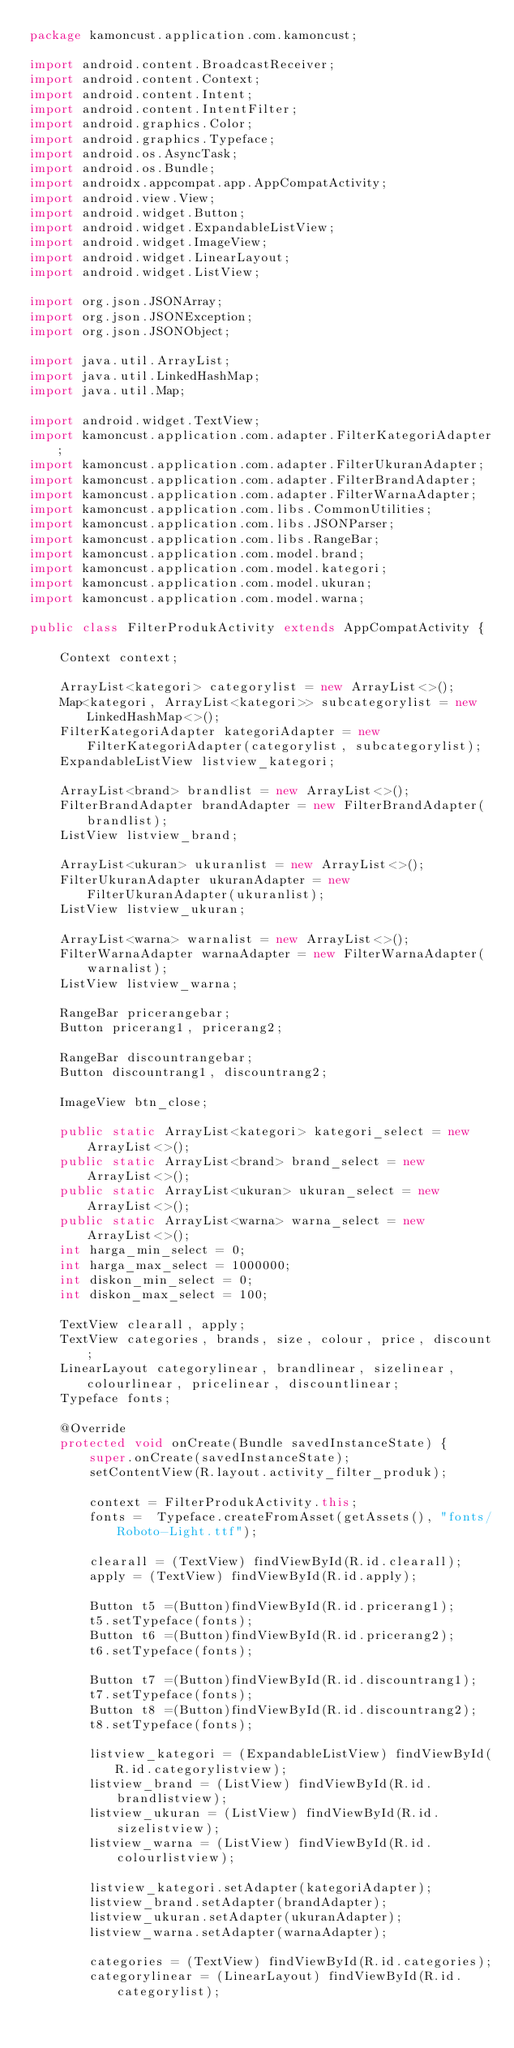<code> <loc_0><loc_0><loc_500><loc_500><_Java_>package kamoncust.application.com.kamoncust;

import android.content.BroadcastReceiver;
import android.content.Context;
import android.content.Intent;
import android.content.IntentFilter;
import android.graphics.Color;
import android.graphics.Typeface;
import android.os.AsyncTask;
import android.os.Bundle;
import androidx.appcompat.app.AppCompatActivity;
import android.view.View;
import android.widget.Button;
import android.widget.ExpandableListView;
import android.widget.ImageView;
import android.widget.LinearLayout;
import android.widget.ListView;

import org.json.JSONArray;
import org.json.JSONException;
import org.json.JSONObject;

import java.util.ArrayList;
import java.util.LinkedHashMap;
import java.util.Map;

import android.widget.TextView;
import kamoncust.application.com.adapter.FilterKategoriAdapter;
import kamoncust.application.com.adapter.FilterUkuranAdapter;
import kamoncust.application.com.adapter.FilterBrandAdapter;
import kamoncust.application.com.adapter.FilterWarnaAdapter;
import kamoncust.application.com.libs.CommonUtilities;
import kamoncust.application.com.libs.JSONParser;
import kamoncust.application.com.libs.RangeBar;
import kamoncust.application.com.model.brand;
import kamoncust.application.com.model.kategori;
import kamoncust.application.com.model.ukuran;
import kamoncust.application.com.model.warna;

public class FilterProdukActivity extends AppCompatActivity {

    Context context;

    ArrayList<kategori> categorylist = new ArrayList<>();
    Map<kategori, ArrayList<kategori>> subcategorylist = new LinkedHashMap<>();
    FilterKategoriAdapter kategoriAdapter = new FilterKategoriAdapter(categorylist, subcategorylist);
    ExpandableListView listview_kategori;

    ArrayList<brand> brandlist = new ArrayList<>();
    FilterBrandAdapter brandAdapter = new FilterBrandAdapter(brandlist);
    ListView listview_brand;

    ArrayList<ukuran> ukuranlist = new ArrayList<>();
    FilterUkuranAdapter ukuranAdapter = new FilterUkuranAdapter(ukuranlist);
    ListView listview_ukuran;

    ArrayList<warna> warnalist = new ArrayList<>();
    FilterWarnaAdapter warnaAdapter = new FilterWarnaAdapter(warnalist);
    ListView listview_warna;

    RangeBar pricerangebar;
    Button pricerang1, pricerang2;

    RangeBar discountrangebar;
    Button discountrang1, discountrang2;

    ImageView btn_close;

    public static ArrayList<kategori> kategori_select = new ArrayList<>();
    public static ArrayList<brand> brand_select = new ArrayList<>();
    public static ArrayList<ukuran> ukuran_select = new ArrayList<>();
    public static ArrayList<warna> warna_select = new ArrayList<>();
    int harga_min_select = 0;
    int harga_max_select = 1000000;
    int diskon_min_select = 0;
    int diskon_max_select = 100;

    TextView clearall, apply;
    TextView categories, brands, size, colour, price, discount;
    LinearLayout categorylinear, brandlinear, sizelinear, colourlinear, pricelinear, discountlinear;
    Typeface fonts;

    @Override
    protected void onCreate(Bundle savedInstanceState) {
        super.onCreate(savedInstanceState);
        setContentView(R.layout.activity_filter_produk);
        
        context = FilterProdukActivity.this;
        fonts =  Typeface.createFromAsset(getAssets(), "fonts/Roboto-Light.ttf");

        clearall = (TextView) findViewById(R.id.clearall);
        apply = (TextView) findViewById(R.id.apply);

        Button t5 =(Button)findViewById(R.id.pricerang1);
        t5.setTypeface(fonts);
        Button t6 =(Button)findViewById(R.id.pricerang2);
        t6.setTypeface(fonts);

        Button t7 =(Button)findViewById(R.id.discountrang1);
        t7.setTypeface(fonts);
        Button t8 =(Button)findViewById(R.id.discountrang2);
        t8.setTypeface(fonts);

        listview_kategori = (ExpandableListView) findViewById(R.id.categorylistview);
        listview_brand = (ListView) findViewById(R.id.brandlistview);
        listview_ukuran = (ListView) findViewById(R.id.sizelistview);
        listview_warna = (ListView) findViewById(R.id.colourlistview);

        listview_kategori.setAdapter(kategoriAdapter);
        listview_brand.setAdapter(brandAdapter);
        listview_ukuran.setAdapter(ukuranAdapter);
        listview_warna.setAdapter(warnaAdapter);
        
        categories = (TextView) findViewById(R.id.categories);
        categorylinear = (LinearLayout) findViewById(R.id.categorylist);
</code> 